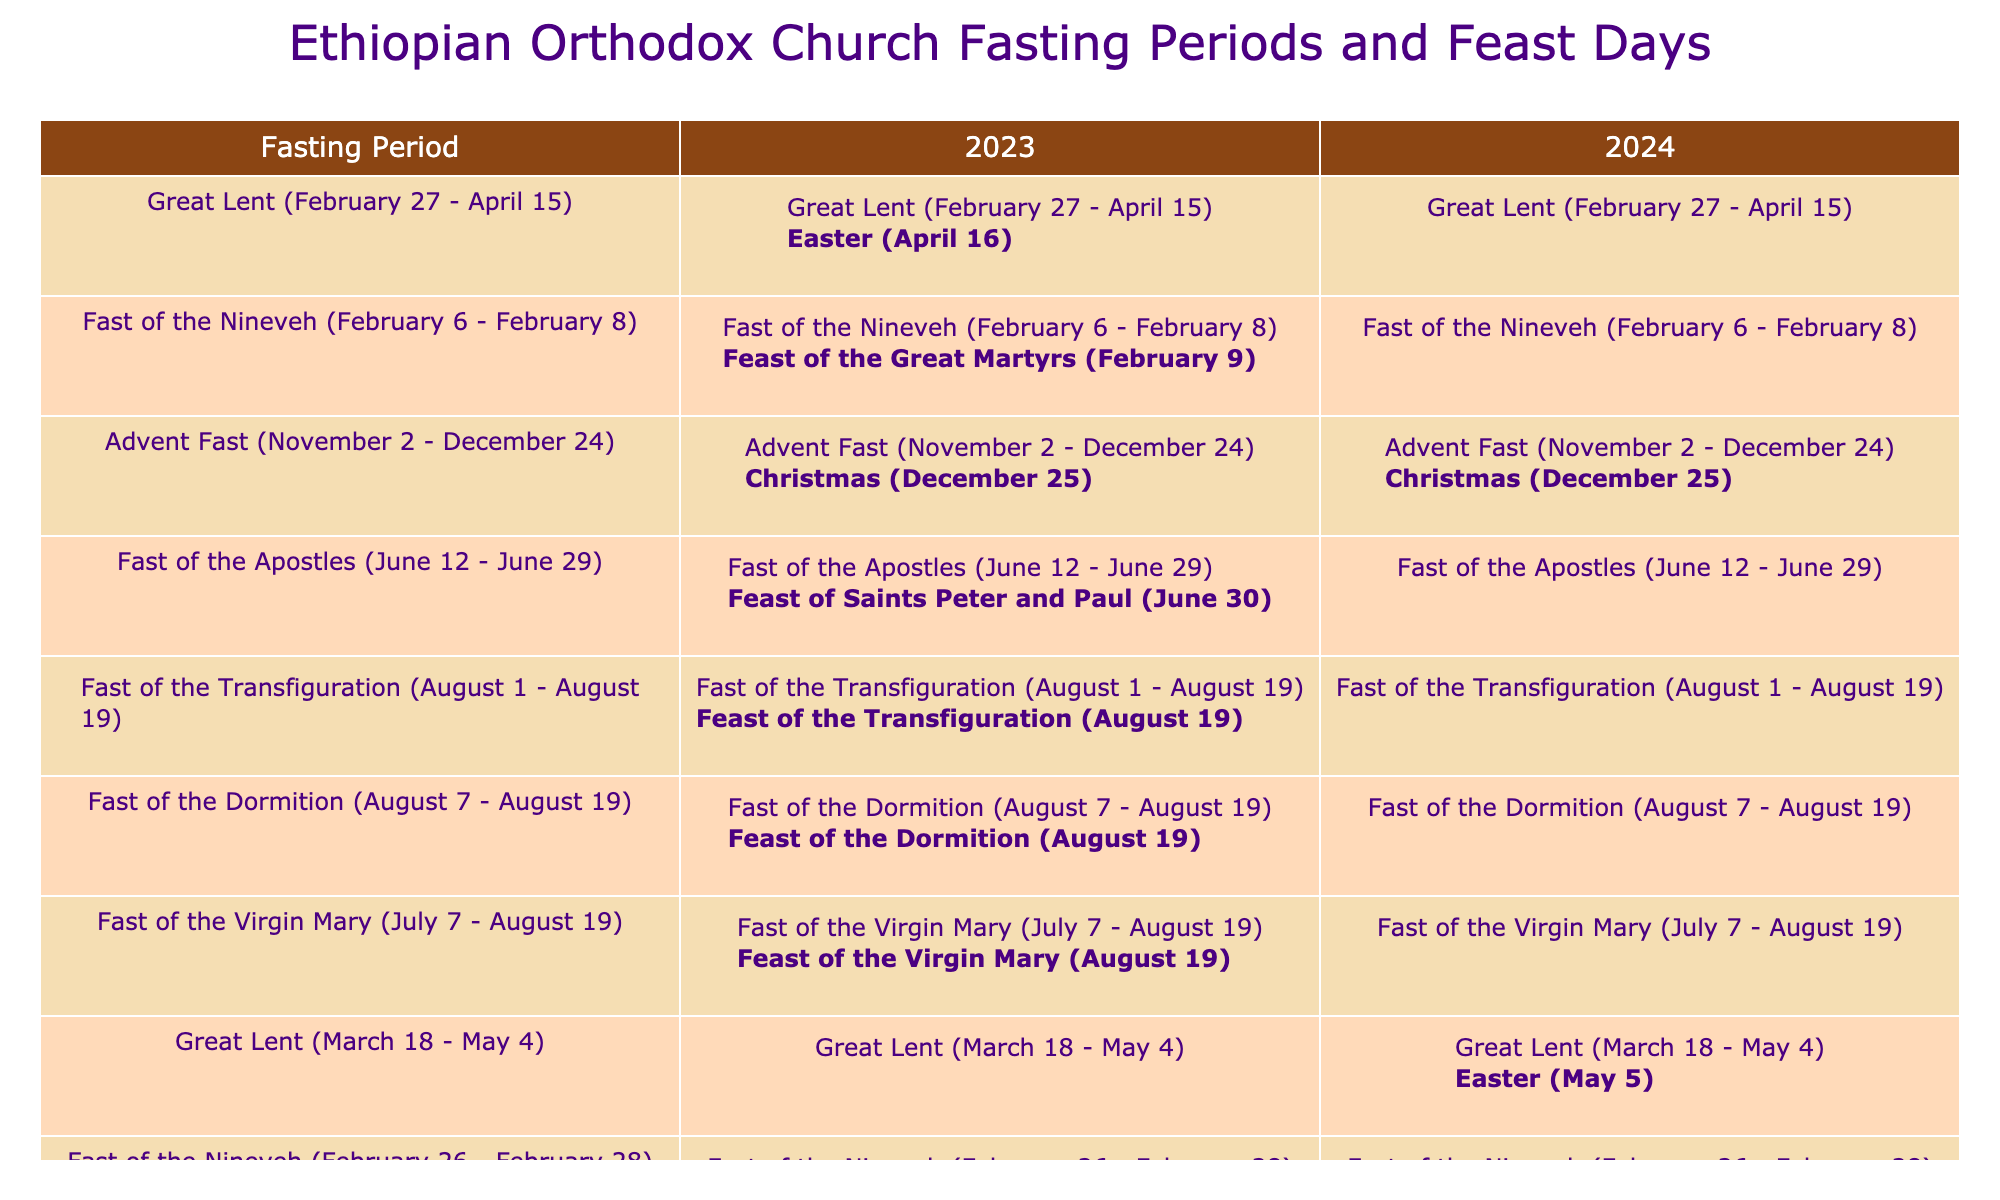What is the feast day following the Great Lent in 2023? The table indicates that after the Great Lent (February 27 - April 15) in 2023, the corresponding feast day is Easter, which is celebrated on April 16.
Answer: Easter (April 16) How many fasting periods are there in 2024? By examining the table, there are four listed fasting periods for 2024: Great Lent, Fast of the Nineveh, Advent Fast, and Fast of the Apostles.
Answer: 4 Is the Fast of the Virgin Mary observed in 2024? Looking at the table, the Fast of the Virgin Mary is not mentioned under 2024; it is only shown for 2023. Therefore, it is not observed in 2024.
Answer: No What is the fasting period before Christmas in 2023? The table shows that the Advent Fast (November 2 - December 24) is the fasting period right before Christmas in 2023.
Answer: Advent Fast (November 2 - December 24) What is the difference in the dates of the Great Lent between 2023 and 2024? In 2023, Great Lent starts on February 27 and ends on April 15. In 2024, it starts on March 18 and ends on May 4. The difference between the start date in 2023 and 2024 is 19 days (February 27 to March 18) whereas the end dates have about 19 days difference as well.
Answer: 19 days What feast day follows the Fast of the Apostles in both years 2023 and 2024? According to the table, the feast day following the Fast of the Apostles is the same: Feast of Saints Peter and Paul, which occurs on June 30 in both 2023 and 2024.
Answer: Feast of Saints Peter and Paul (June 30) Which year has the Fast of the Nineveh starting on February 26? The table states that in 2024, the Fast of the Nineveh begins on February 26 and ends on February 28. Looking at 2023, the date did not match this criterion.
Answer: 2024 Are there any overlapping fasting periods in 2023? Analyzing the table reveals that the Fast of the Virgin Mary (July 7 - August 19) overlaps with the Fast of the Transfiguration (August 1 - August 19) in 2023. This confirms there are overlapping fasting periods.
Answer: Yes What is the feast day for the Fast of the Transfiguration in 2023? By referring to the table, the feast day for the Fast of the Transfiguration, which occurs during the same period, is noted as the Feast of the Transfiguration, celebrated on August 19 in 2023.
Answer: Feast of the Transfiguration (August 19) 